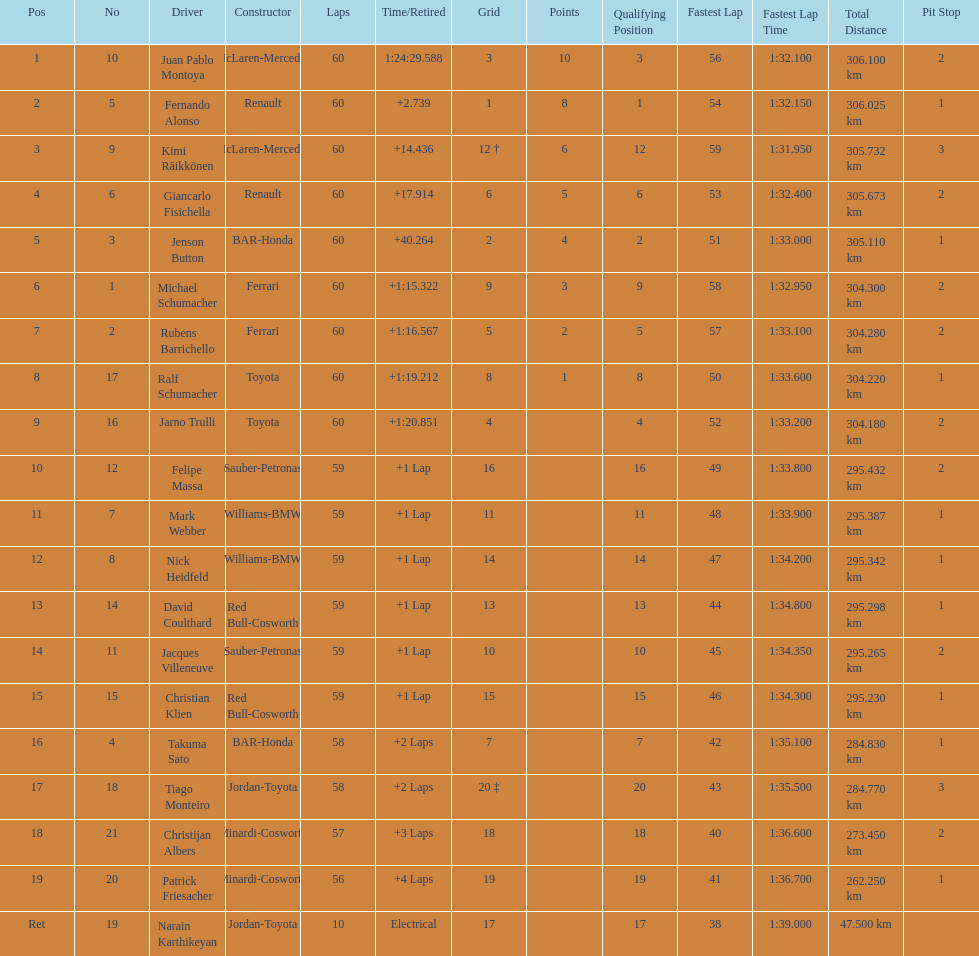Is there a points difference between the 9th position and 19th position on the list? No. 